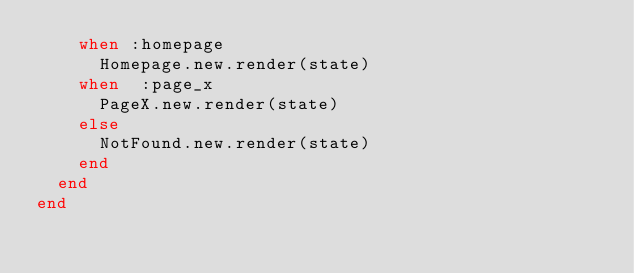Convert code to text. <code><loc_0><loc_0><loc_500><loc_500><_Ruby_>    when :homepage
      Homepage.new.render(state)
    when  :page_x
      PageX.new.render(state)
    else
      NotFound.new.render(state)
    end
  end
end
</code> 